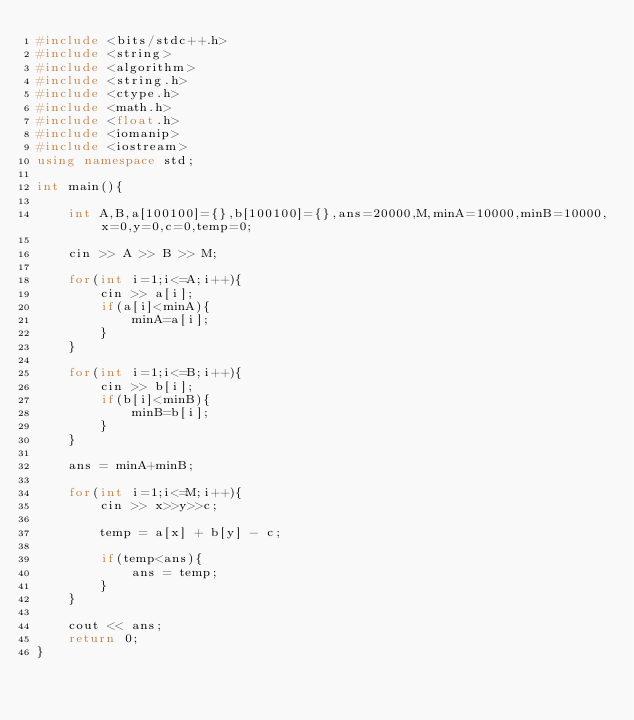<code> <loc_0><loc_0><loc_500><loc_500><_C++_>#include <bits/stdc++.h>
#include <string>
#include <algorithm>
#include <string.h>
#include <ctype.h>
#include <math.h>
#include <float.h>
#include <iomanip>
#include <iostream>
using namespace std;

int main(){

    int A,B,a[100100]={},b[100100]={},ans=20000,M,minA=10000,minB=10000,x=0,y=0,c=0,temp=0;

    cin >> A >> B >> M;

    for(int i=1;i<=A;i++){
        cin >> a[i];
        if(a[i]<minA){
            minA=a[i];
        }
    }

    for(int i=1;i<=B;i++){
        cin >> b[i];
        if(b[i]<minB){
            minB=b[i];
        }
    }

    ans = minA+minB;

    for(int i=1;i<=M;i++){
        cin >> x>>y>>c;

        temp = a[x] + b[y] - c;

        if(temp<ans){
            ans = temp;
        }
    }

    cout << ans;
    return 0;
}</code> 